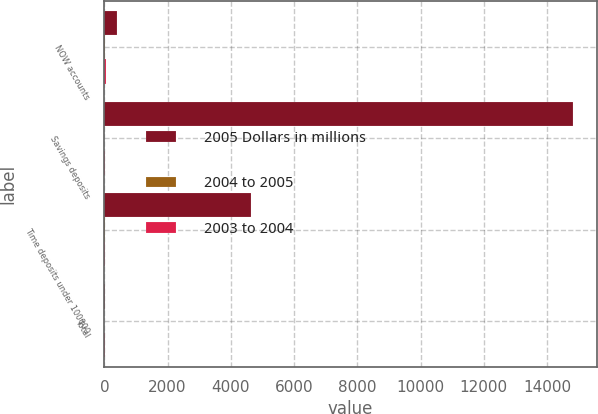Convert chart. <chart><loc_0><loc_0><loc_500><loc_500><stacked_bar_chart><ecel><fcel>NOW accounts<fcel>Savings deposits<fcel>Time deposits under 100000<fcel>Total<nl><fcel>2005 Dollars in millions<fcel>400<fcel>14827<fcel>4624<fcel>15<nl><fcel>2004 to 2005<fcel>27<fcel>3<fcel>8<fcel>1<nl><fcel>2003 to 2004<fcel>46<fcel>15<fcel>10<fcel>9<nl></chart> 